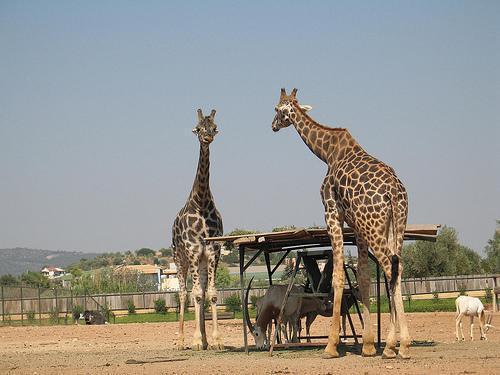How many legs does each giraffe have?
Give a very brief answer. 4. How many giraffes are there?
Give a very brief answer. 2. How many giraffes are in the picture?
Give a very brief answer. 2. 